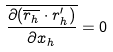Convert formula to latex. <formula><loc_0><loc_0><loc_500><loc_500>\overline { \frac { \partial ( \overline { r _ { h } } \cdot r _ { h } ^ { \prime } ) } { \partial x _ { h } } } = 0</formula> 